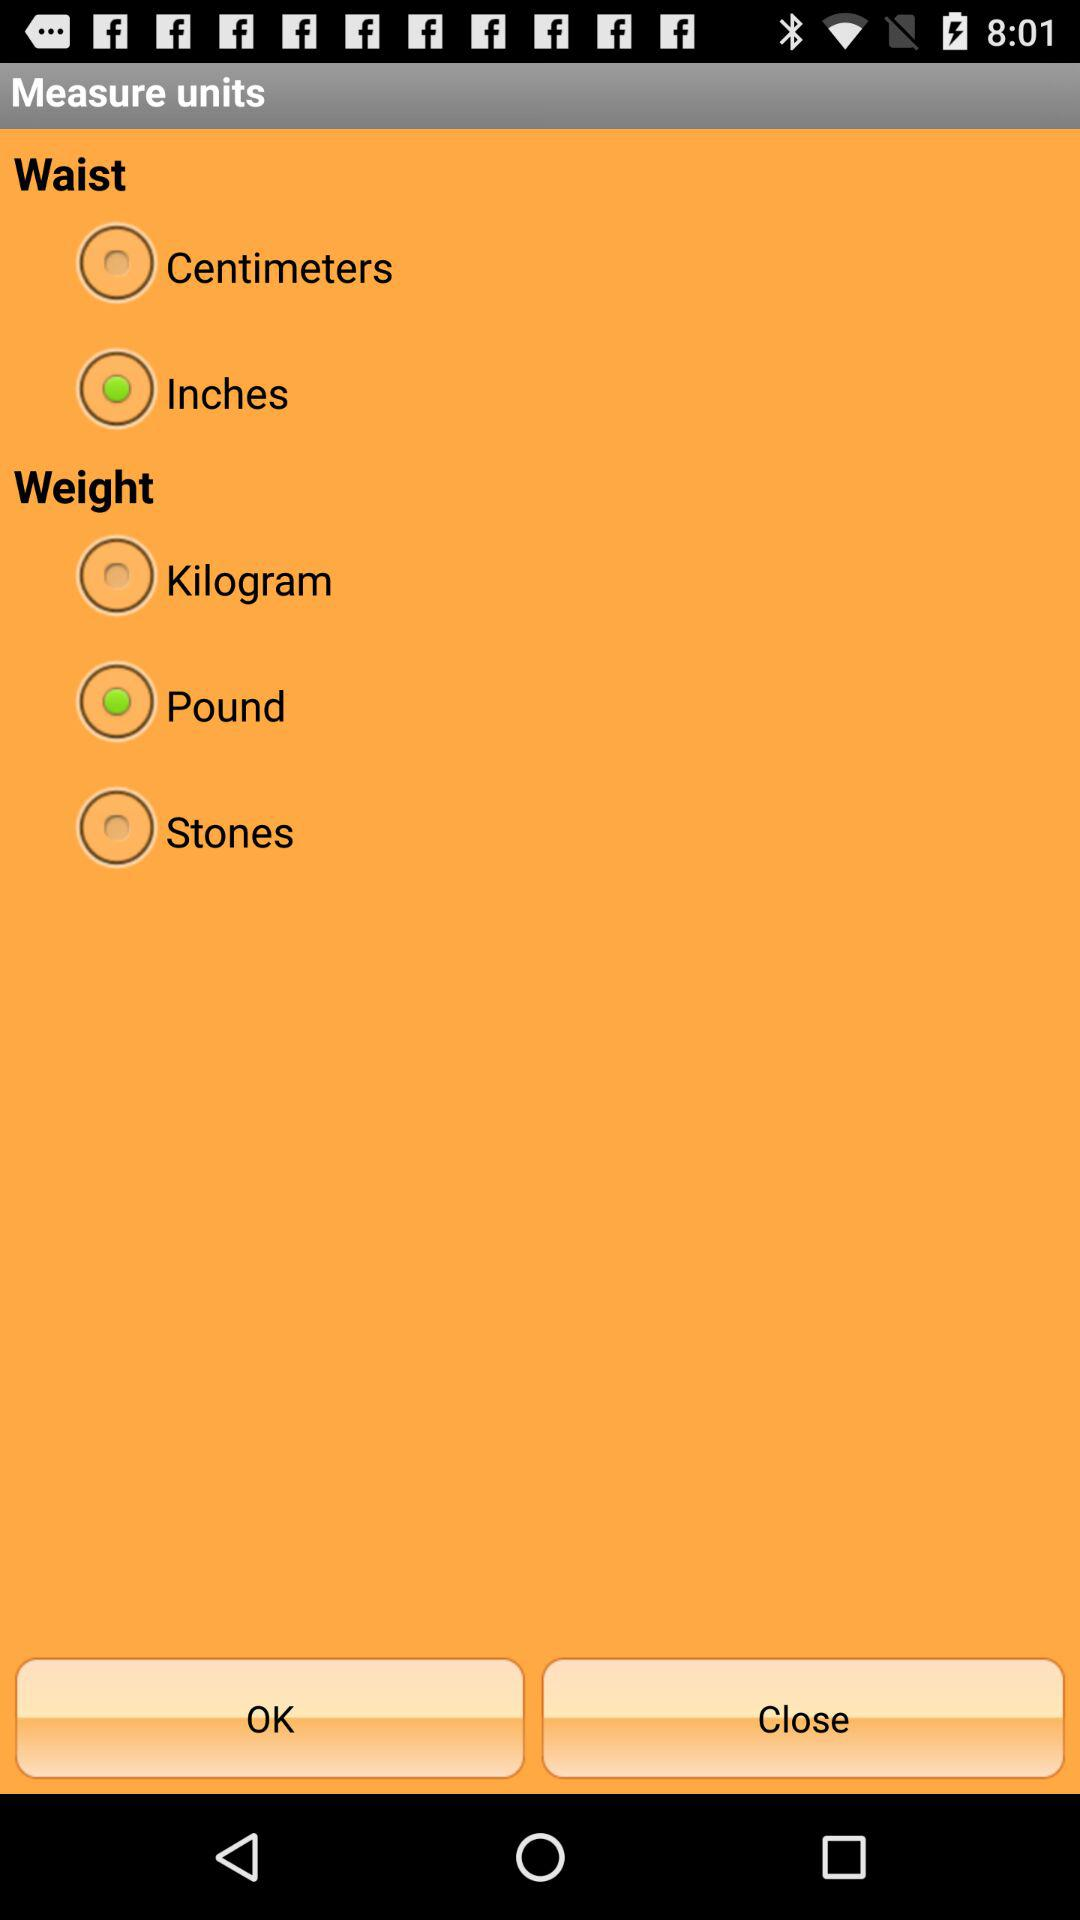What are the different units for measuring waist? The different units for measuring waist are centimeters and inches. 